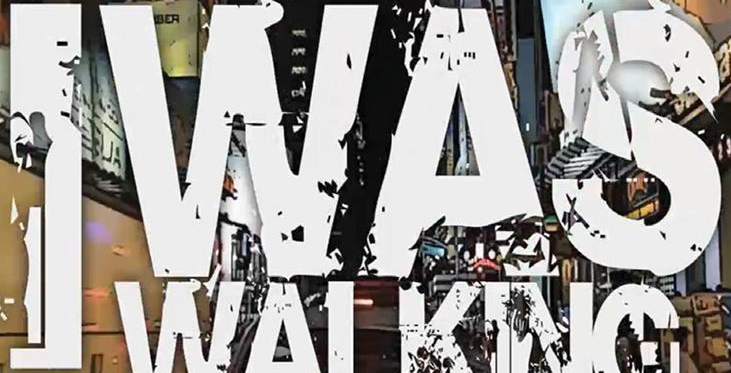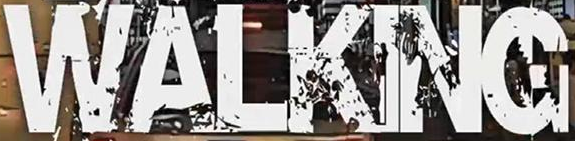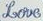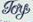What words are shown in these images in order, separated by a semicolon? IWAS; WALKING; Love; Toy 